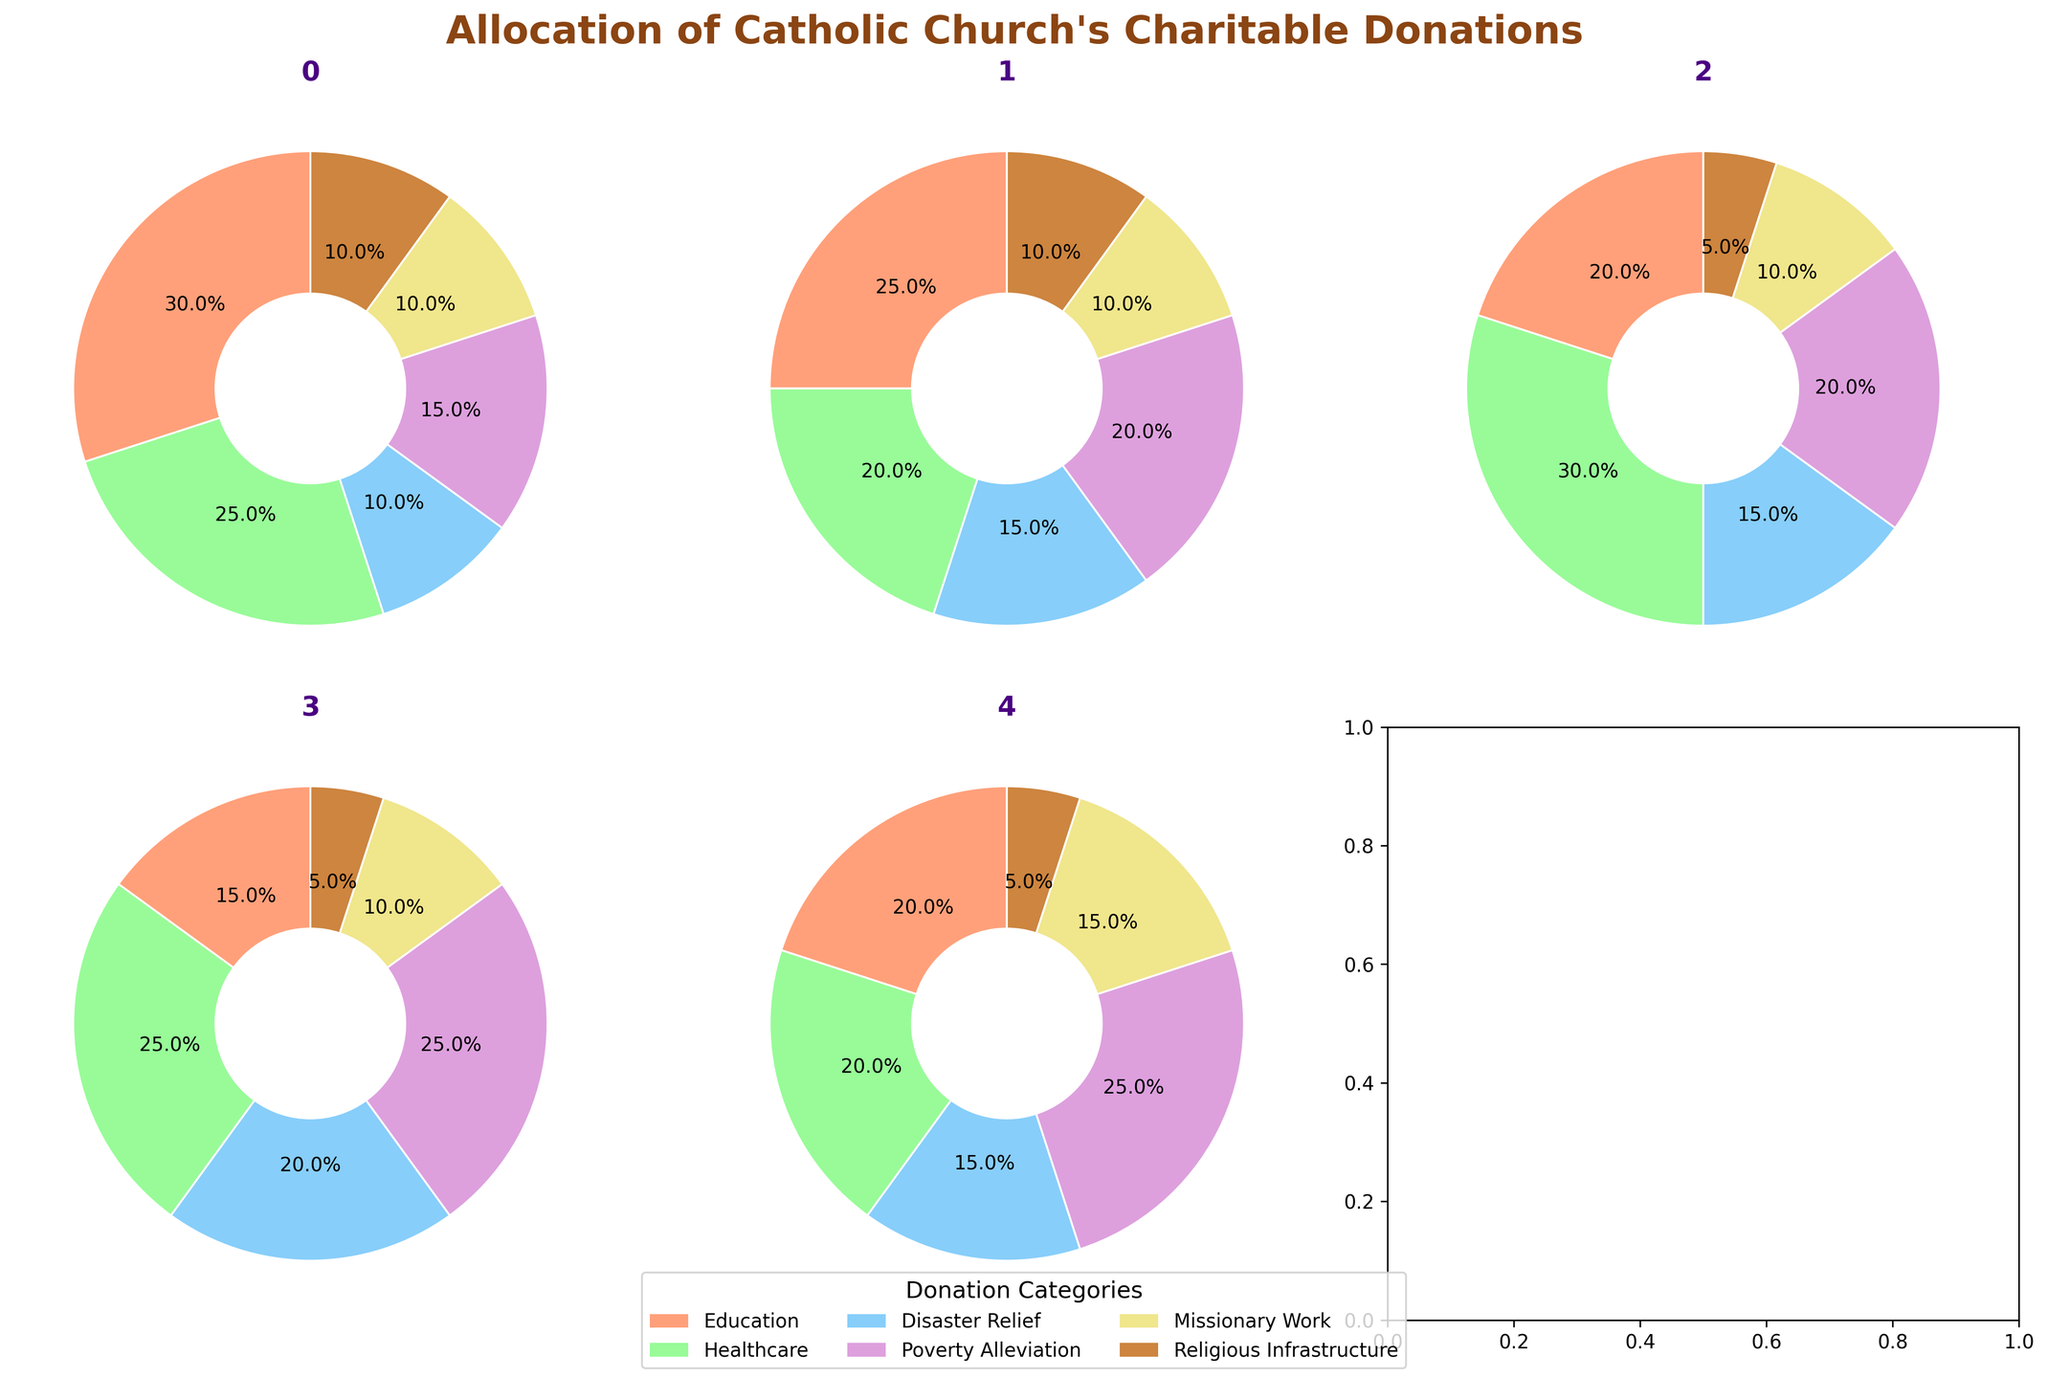How much of North America's charitable donations go to Education and Healthcare combined? In the pie chart for North America, the slices for Education and Healthcare are labeled with 30% and 25%, respectively. Adding these percentages together, we get 30% + 25% = 55%.
Answer: 55% Which region allocates the highest percentage of donations to Healthcare? By looking at the pie charts, we can see that Africa allocates the highest percentage to Healthcare with 30%.
Answer: Africa What is the title of the figure? The title of the figure is "Allocation of Catholic Church's Charitable Donations," as indicated at the top of the plot.
Answer: Allocation of Catholic Church's Charitable Donations Which cause receives the least amount of donations in South America? In the pie chart for South America, the cause with the smallest slice, or percentage, is Religious Infrastructure, with 5%.
Answer: Religious Infrastructure Compare the percentage of donations to Disaster Relief in Asia and Europe. Which has a higher percentage, and by how much? The pie chart for Asia shows 20% for Disaster Relief, while Europe shows 15%. Therefore, Asia allocates 5% more to Disaster Relief than Europe.
Answer: Asia by 5% What is the color representing Missionary Work across all regions? The legend at the bottom of the figure shows that Missionary Work is represented by the color purple in all pie charts.
Answer: Purple How do the percentages allocated to Poverty Alleviation compare among North America, Asia, and South America? The pie charts show North America allocates 15%, Asia allocates 25%, and South America allocates 25% to Poverty Alleviation. Both Asia and South America allocate 10% more than North America to this cause.
Answer: North America: 15%, Asia: 25%, South America: 25% Which cause has the most uniform allocation percentages across all regions? By examining the pie charts, we see that Missionary Work allocates 10% in most regions and slightly varies around this number, demonstrating the most uniform allocation.
Answer: Missionary Work What is the combined percentage of donations allocated to Religious Infrastructure across all regions? Adding the percentages for Religious Infrastructure from all regions: North America (10%), Europe (10%), Africa (5%), Asia (5%), and South America (5%), we get 10% + 10% + 5% + 5% + 5% = 35%.
Answer: 35% In which region is Education given the second-highest allocation of donations, and what is the percentage? The pie chart for North America shows Education with the highest allocation at 30%, followed by Healthcare at 25%. Therefore, North America's Education receives the second-highest overall donation percentage at 30%.
Answer: North America, 30% 